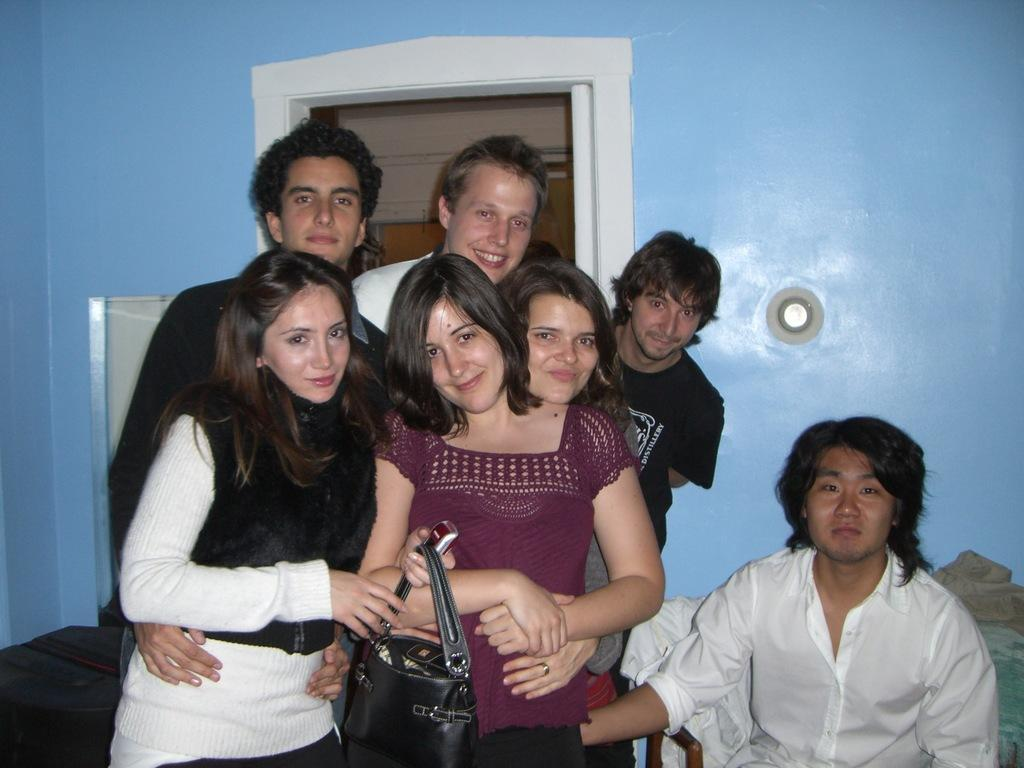How many people are in the image? There are persons standing in the image. What is one person holding in the image? A person is holding a bag. What is the position of one person in the image? There is a person sitting on a chair in the image. What can be seen behind the people in the image? There is a wall visible in the image. What color is the sweater worn by the father in the image? There is no sweater or father mentioned in the image; it only states that there are persons standing and one person is sitting on a chair. 